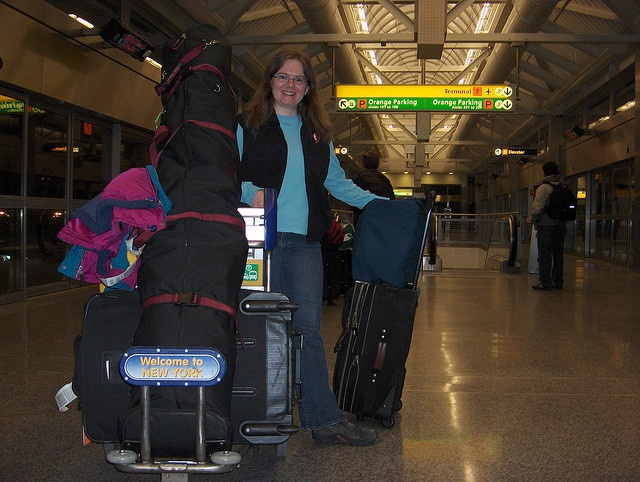Describe the objects in this image and their specific colors. I can see suitcase in black, maroon, and gray tones, people in black, teal, and maroon tones, suitcase in black, gray, and darkblue tones, suitcase in black and gray tones, and backpack in black, gray, navy, and blue tones in this image. 